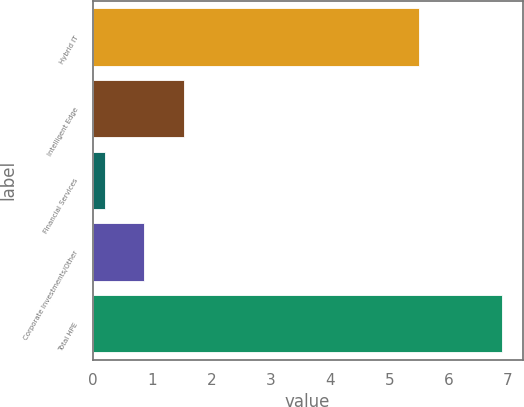<chart> <loc_0><loc_0><loc_500><loc_500><bar_chart><fcel>Hybrid IT<fcel>Intelligent Edge<fcel>Financial Services<fcel>Corporate Investments/Other<fcel>Total HPE<nl><fcel>5.5<fcel>1.54<fcel>0.2<fcel>0.87<fcel>6.9<nl></chart> 